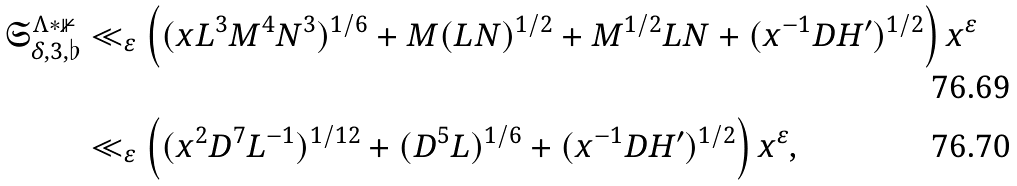<formula> <loc_0><loc_0><loc_500><loc_500>\mathfrak { S } _ { \delta , 3 , \flat } ^ { \Lambda * \mathbb { 1 } } & \ll _ { \varepsilon } \left ( ( x L ^ { 3 } M ^ { 4 } N ^ { 3 } ) ^ { 1 / 6 } + M ( L N ) ^ { 1 / 2 } + M ^ { 1 / 2 } L N + ( x ^ { - 1 } D H ^ { \prime } ) ^ { 1 / 2 } \right ) x ^ { \varepsilon } \\ & \ll _ { \varepsilon } \left ( ( x ^ { 2 } D ^ { 7 } L ^ { - 1 } ) ^ { 1 / 1 2 } + ( D ^ { 5 } L ) ^ { 1 / 6 } + ( x ^ { - 1 } D H ^ { \prime } ) ^ { 1 / 2 } \right ) x ^ { \varepsilon } ,</formula> 